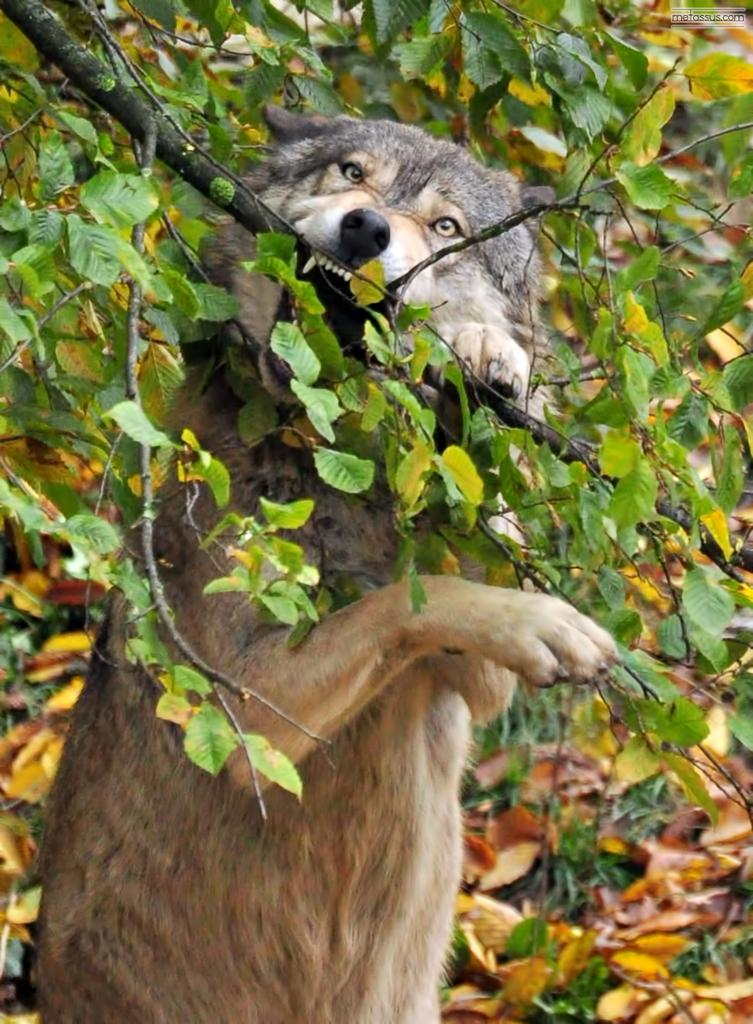What animal is present in the image? There is a dog in the image. What is the dog doing in the image? The dog is biting a stem in the image. What can be seen in the background of the image? There are leaves in the background of the image. What hobbies does the dog have, as seen in the image? The image does not provide information about the dog's hobbies. 